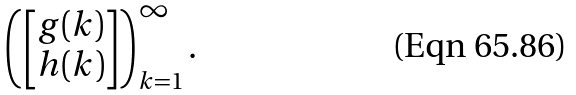Convert formula to latex. <formula><loc_0><loc_0><loc_500><loc_500>\left ( \left [ \begin{matrix} g ( k ) \\ h ( k ) \end{matrix} \right ] \right ) ^ { \infty } _ { k = 1 } .</formula> 